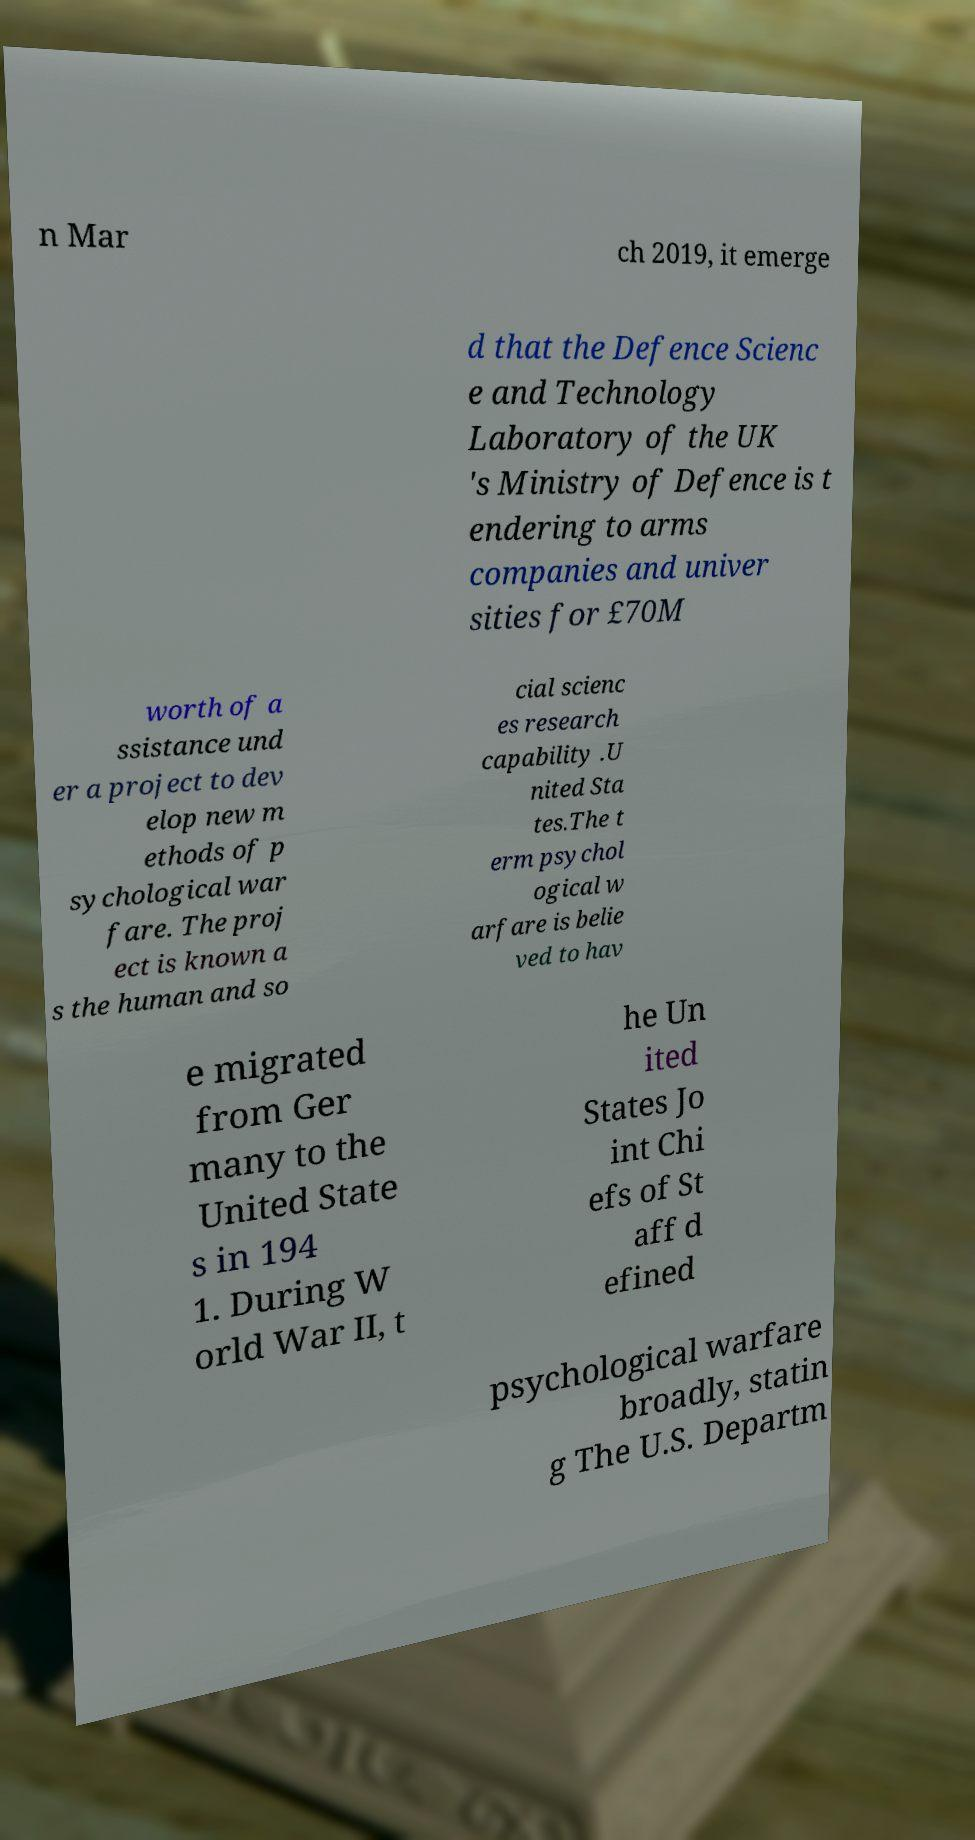For documentation purposes, I need the text within this image transcribed. Could you provide that? n Mar ch 2019, it emerge d that the Defence Scienc e and Technology Laboratory of the UK 's Ministry of Defence is t endering to arms companies and univer sities for £70M worth of a ssistance und er a project to dev elop new m ethods of p sychological war fare. The proj ect is known a s the human and so cial scienc es research capability .U nited Sta tes.The t erm psychol ogical w arfare is belie ved to hav e migrated from Ger many to the United State s in 194 1. During W orld War II, t he Un ited States Jo int Chi efs of St aff d efined psychological warfare broadly, statin g The U.S. Departm 